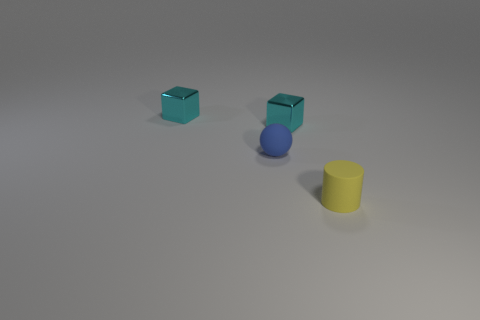What number of other things are there of the same material as the small blue object
Ensure brevity in your answer.  1. There is a tiny rubber thing that is to the right of the tiny rubber sphere; how many tiny matte balls are in front of it?
Ensure brevity in your answer.  0. Is there any other thing that has the same shape as the yellow object?
Your answer should be compact. No. There is a thing left of the blue sphere; is it the same color as the tiny matte thing that is behind the small yellow rubber cylinder?
Offer a very short reply. No. Are there fewer tiny gray shiny cylinders than small metallic things?
Your answer should be very brief. Yes. What is the shape of the metal object that is in front of the cyan block to the left of the small blue rubber ball?
Ensure brevity in your answer.  Cube. Are there any other things that have the same size as the cylinder?
Provide a succinct answer. Yes. What shape is the small rubber thing to the left of the yellow thing right of the small matte object that is behind the matte cylinder?
Provide a short and direct response. Sphere. How many things are tiny yellow cylinders in front of the tiny matte ball or tiny matte things that are to the right of the blue sphere?
Offer a very short reply. 1. There is a rubber cylinder; does it have the same size as the thing that is on the left side of the blue object?
Ensure brevity in your answer.  Yes. 